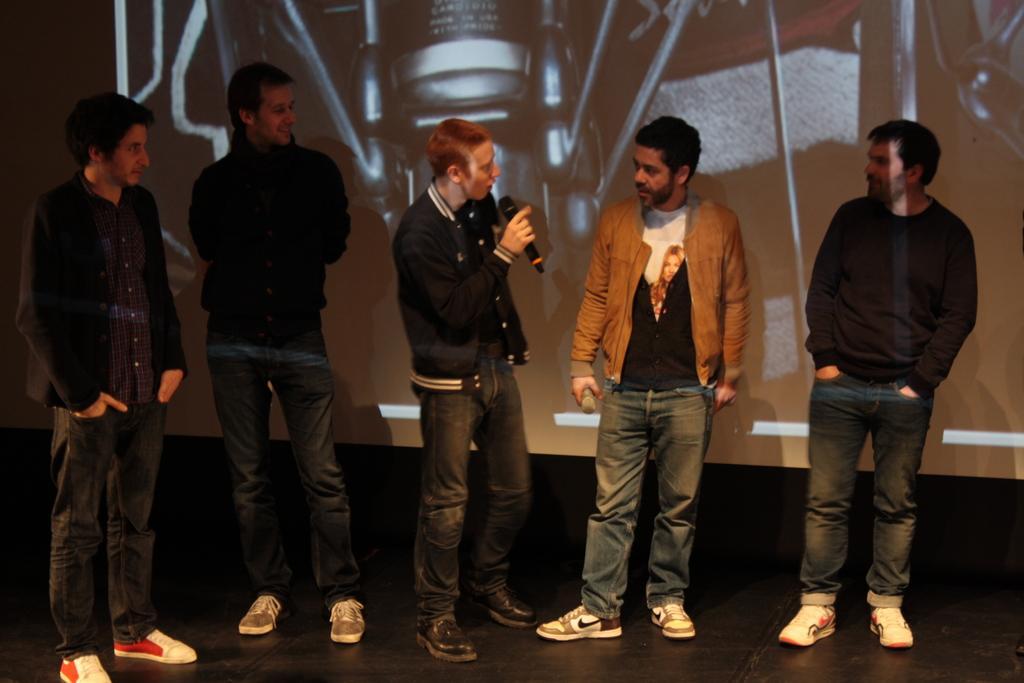Can you describe this image briefly? In this picture we see 5 people standing on the stage. The person in the middle is speaking into a mike and the others are looking at him. 